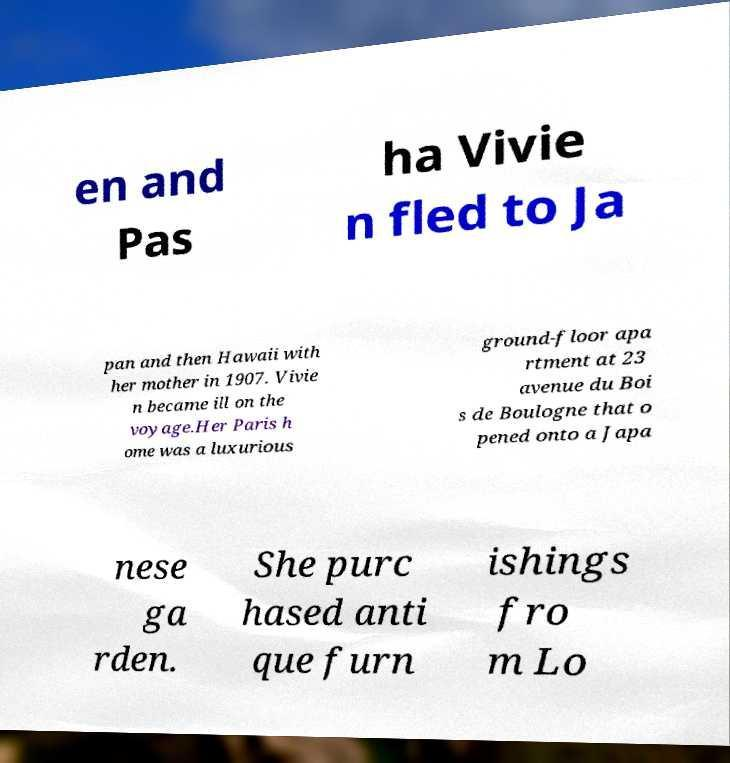For documentation purposes, I need the text within this image transcribed. Could you provide that? en and Pas ha Vivie n fled to Ja pan and then Hawaii with her mother in 1907. Vivie n became ill on the voyage.Her Paris h ome was a luxurious ground-floor apa rtment at 23 avenue du Boi s de Boulogne that o pened onto a Japa nese ga rden. She purc hased anti que furn ishings fro m Lo 